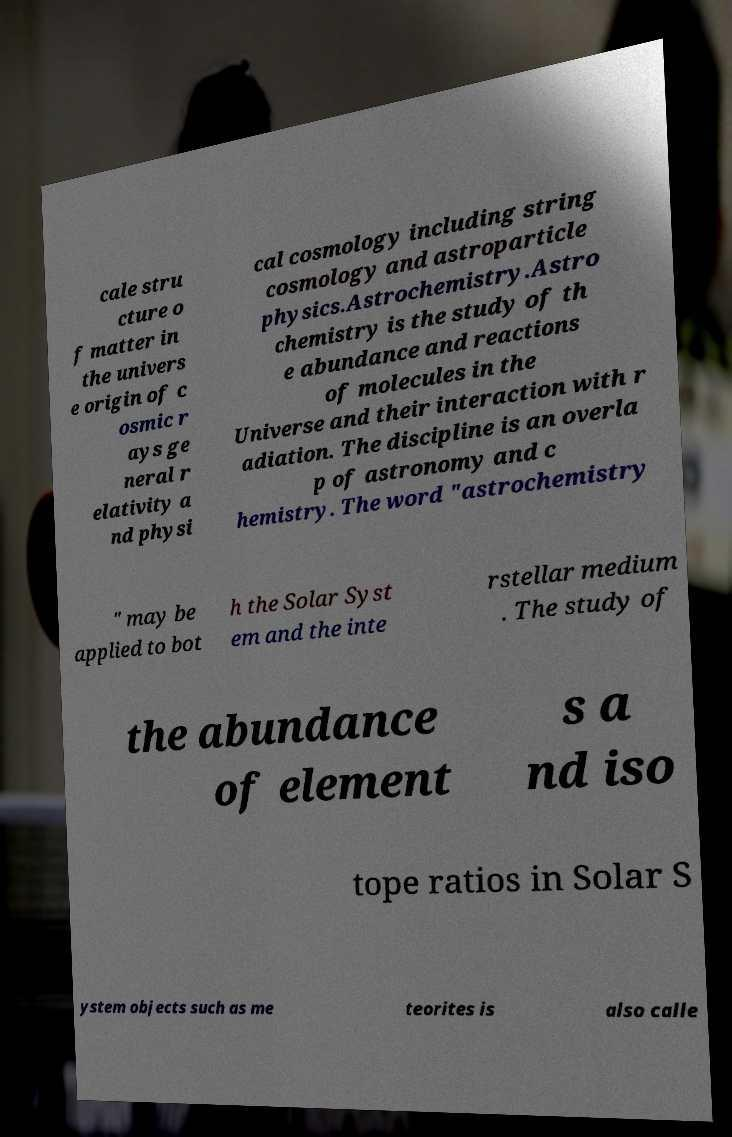There's text embedded in this image that I need extracted. Can you transcribe it verbatim? cale stru cture o f matter in the univers e origin of c osmic r ays ge neral r elativity a nd physi cal cosmology including string cosmology and astroparticle physics.Astrochemistry.Astro chemistry is the study of th e abundance and reactions of molecules in the Universe and their interaction with r adiation. The discipline is an overla p of astronomy and c hemistry. The word "astrochemistry " may be applied to bot h the Solar Syst em and the inte rstellar medium . The study of the abundance of element s a nd iso tope ratios in Solar S ystem objects such as me teorites is also calle 